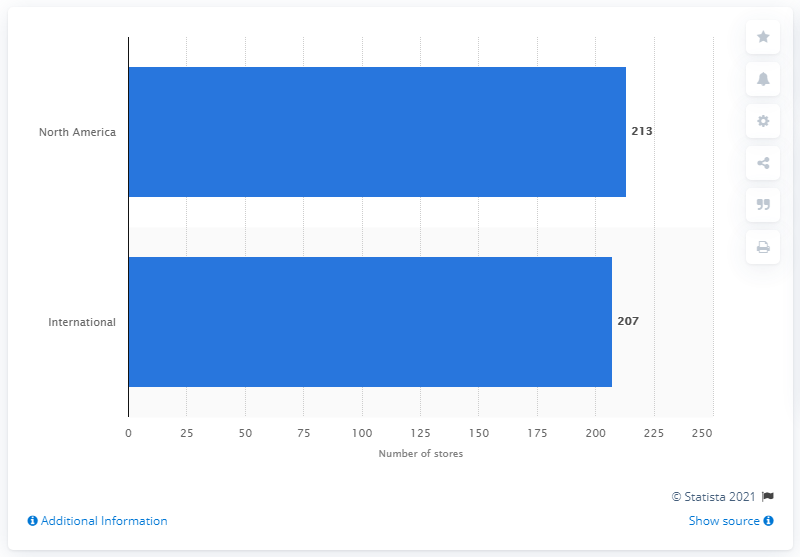Indicate a few pertinent items in this graphic. As of June 27, 2020, Kate Spade had 213 stores in North America. 